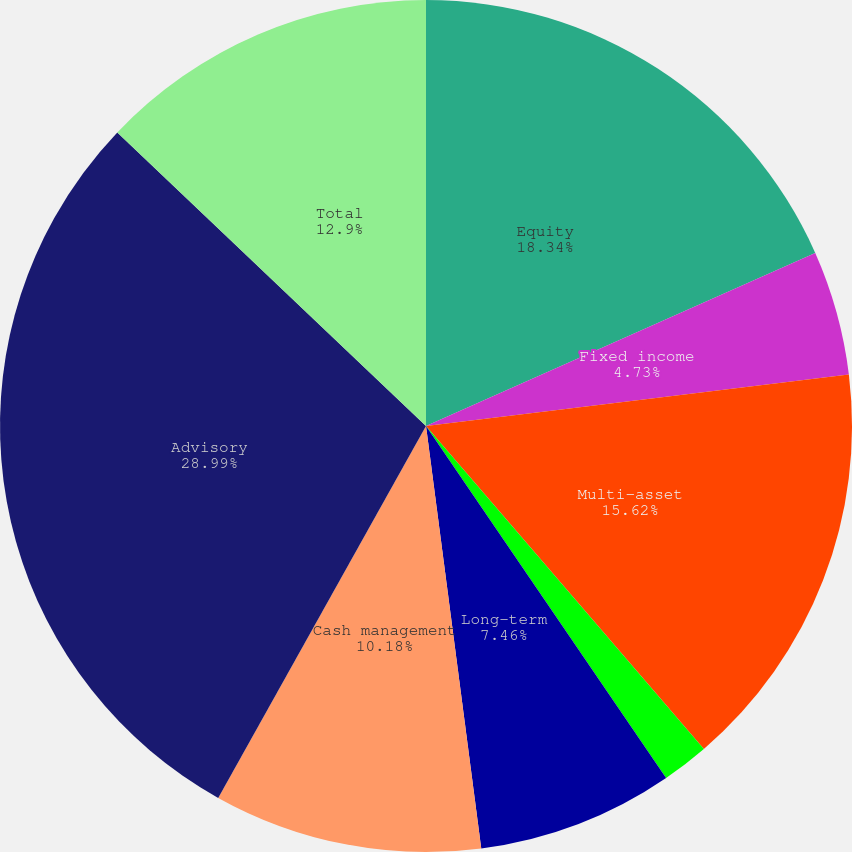Convert chart. <chart><loc_0><loc_0><loc_500><loc_500><pie_chart><fcel>Equity<fcel>Fixed income<fcel>Multi-asset<fcel>Alternatives<fcel>Long-term<fcel>Cash management<fcel>Advisory<fcel>Total<nl><fcel>18.34%<fcel>4.73%<fcel>15.62%<fcel>1.78%<fcel>7.46%<fcel>10.18%<fcel>28.99%<fcel>12.9%<nl></chart> 